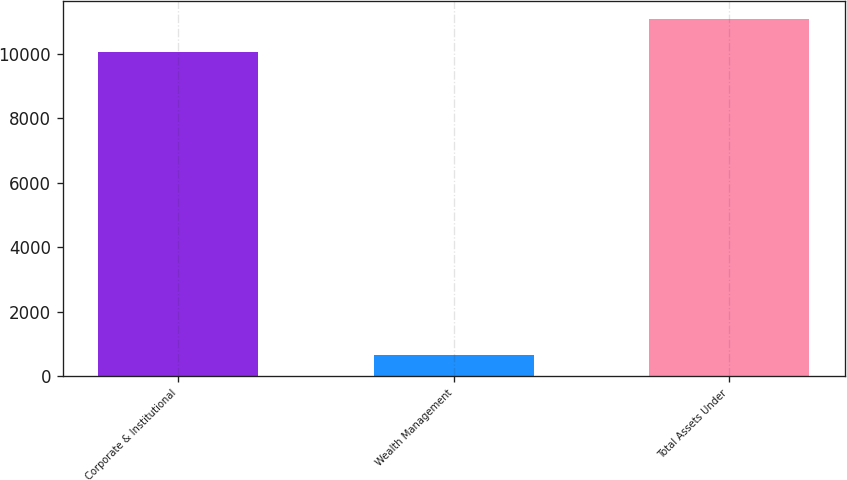Convert chart. <chart><loc_0><loc_0><loc_500><loc_500><bar_chart><fcel>Corporate & Institutional<fcel>Wealth Management<fcel>Total Assets Under<nl><fcel>10066.8<fcel>655.8<fcel>11073.5<nl></chart> 